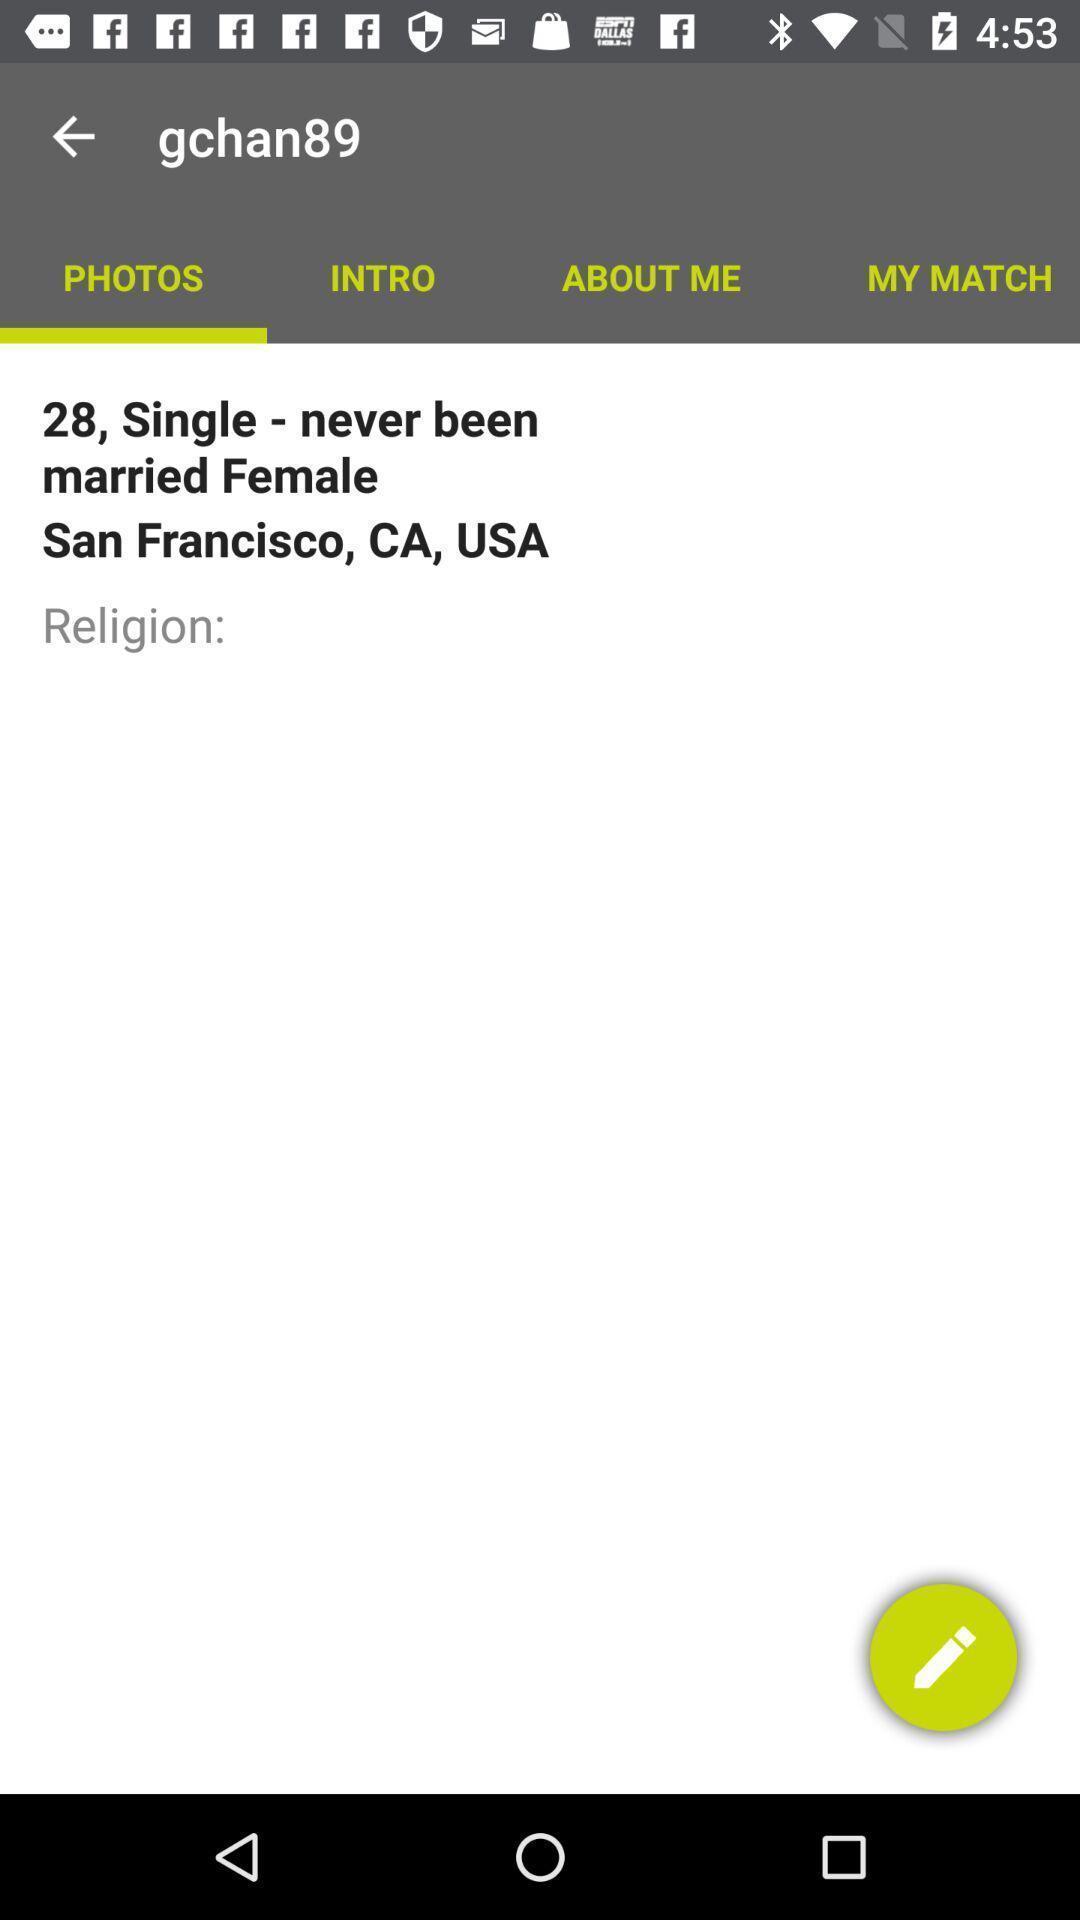Tell me about the visual elements in this screen capture. Page showing information about personal. 